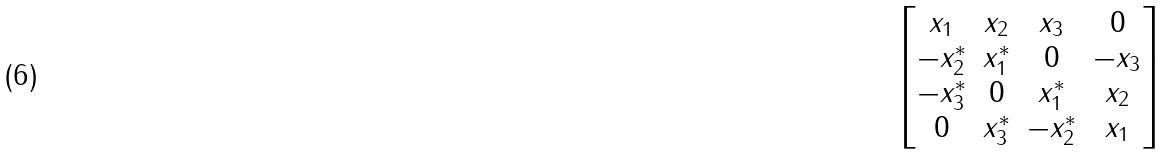Convert formula to latex. <formula><loc_0><loc_0><loc_500><loc_500>\begin{bmatrix} x _ { 1 } & x _ { 2 } & x _ { 3 } & 0 \\ - x _ { 2 } ^ { \ast } & x _ { 1 } ^ { \ast } & 0 & - x _ { 3 } \\ - x _ { 3 } ^ { \ast } & 0 & x _ { 1 } ^ { \ast } & x _ { 2 } \\ 0 & x _ { 3 } ^ { \ast } & - x _ { 2 } ^ { \ast } & x _ { 1 } \end{bmatrix}</formula> 